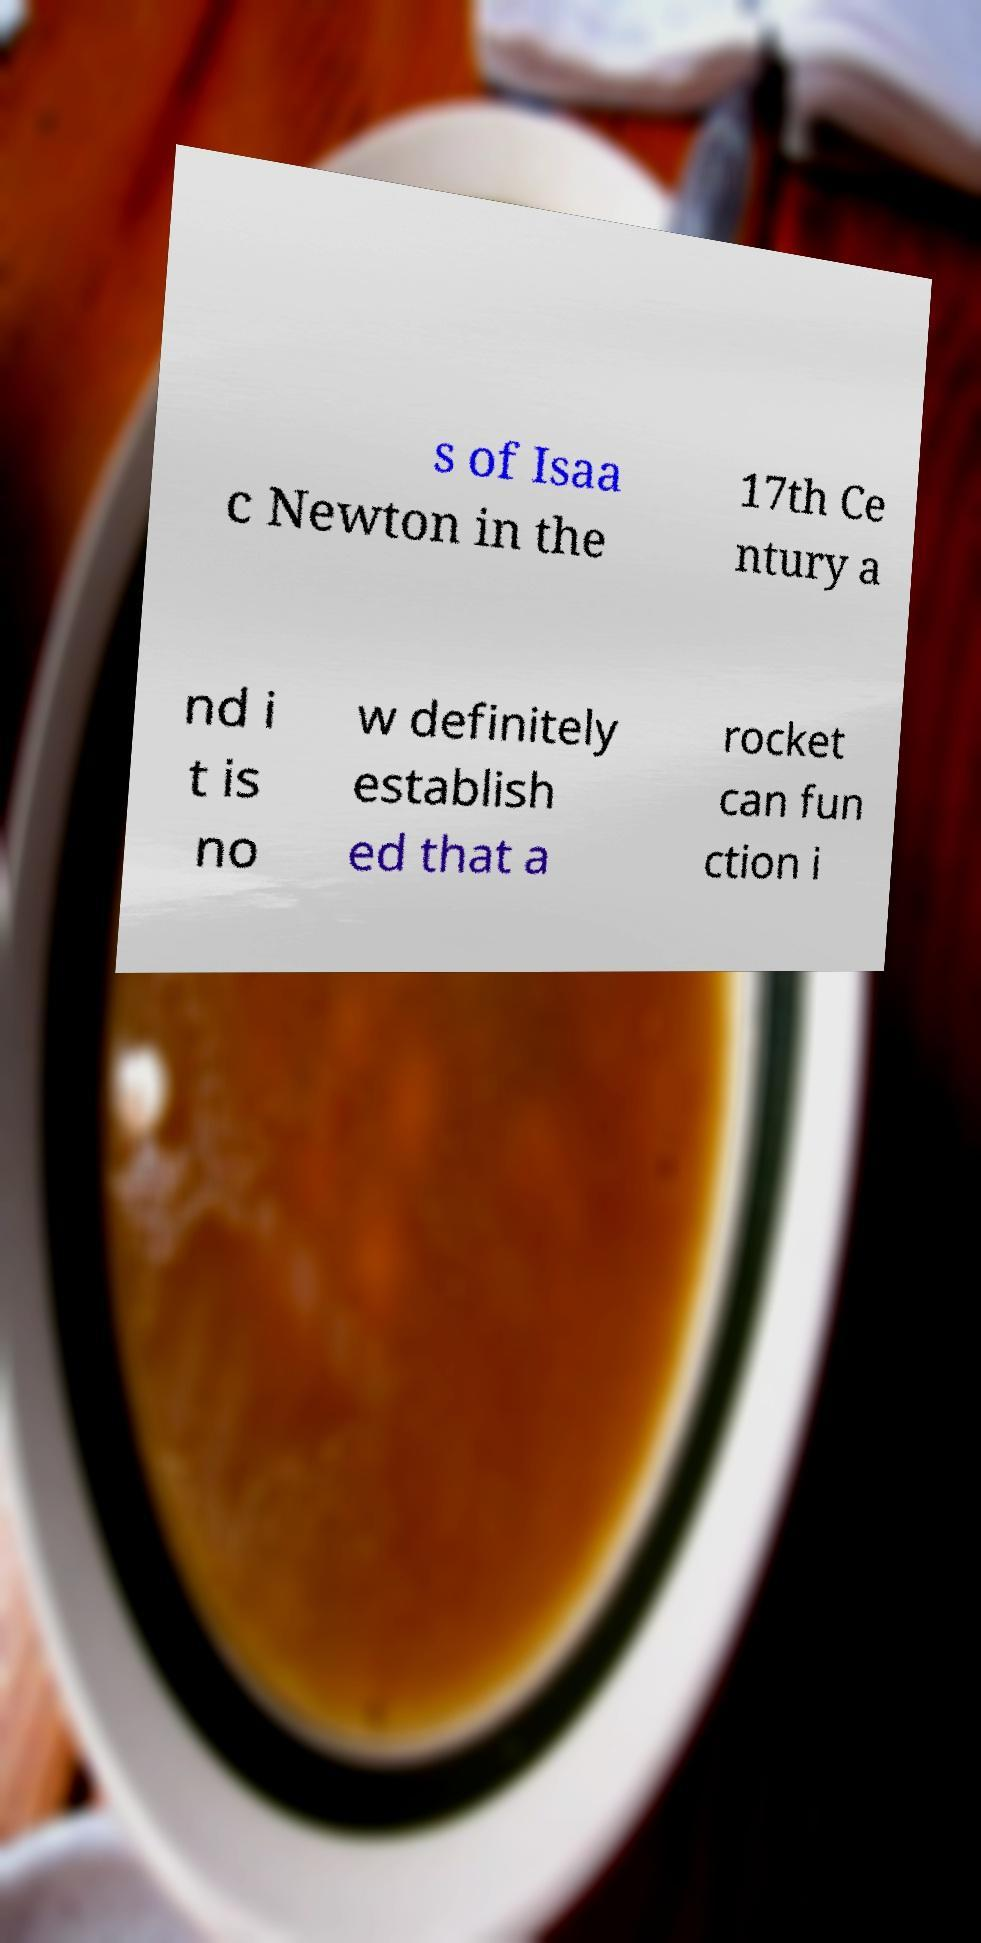Can you accurately transcribe the text from the provided image for me? s of Isaa c Newton in the 17th Ce ntury a nd i t is no w definitely establish ed that a rocket can fun ction i 